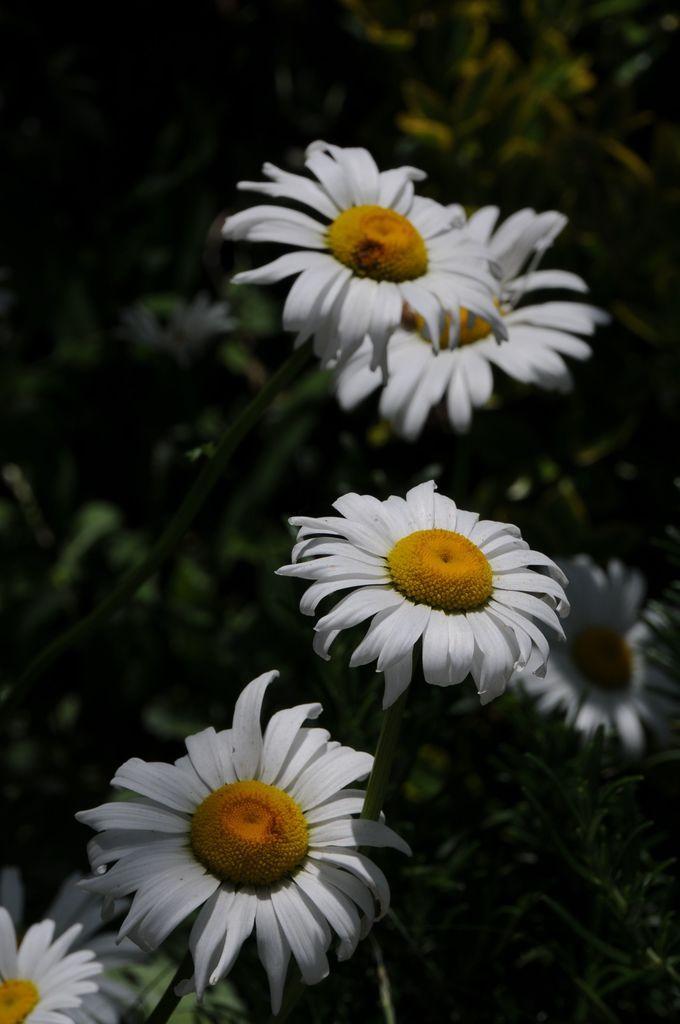In one or two sentences, can you explain what this image depicts? In the image in the center, we can see plants and few flowers, which are in white and yellow color. 